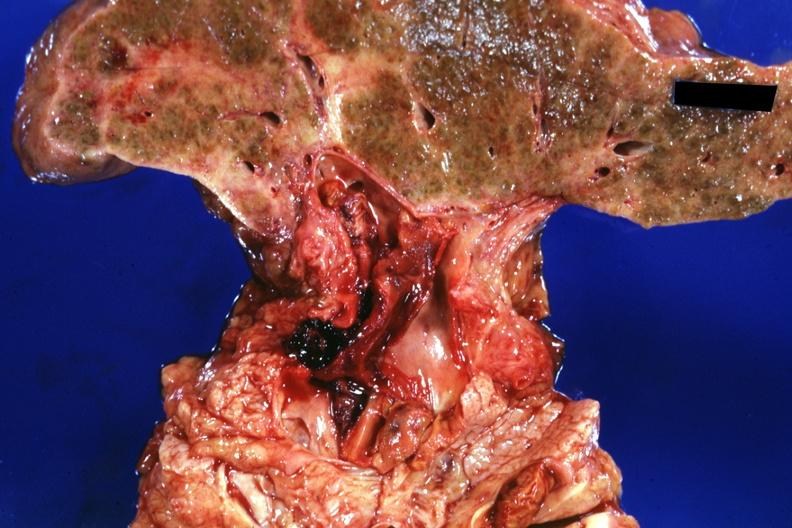what is present?
Answer the question using a single word or phrase. Liver 